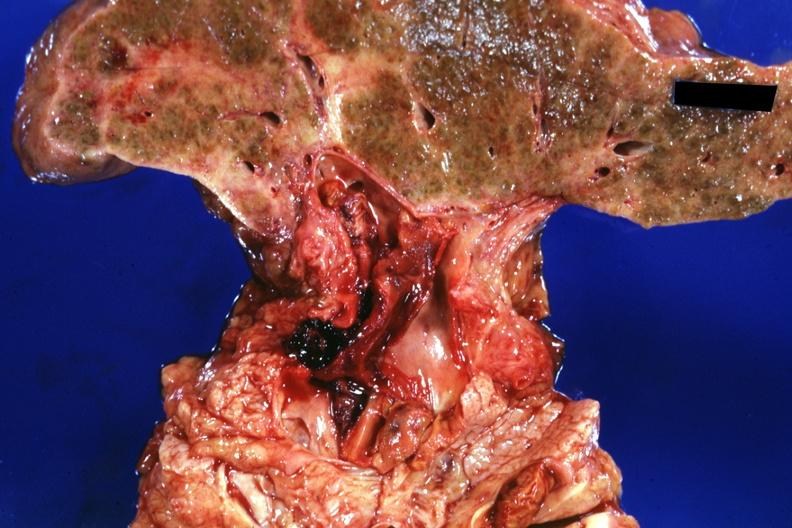what is present?
Answer the question using a single word or phrase. Liver 